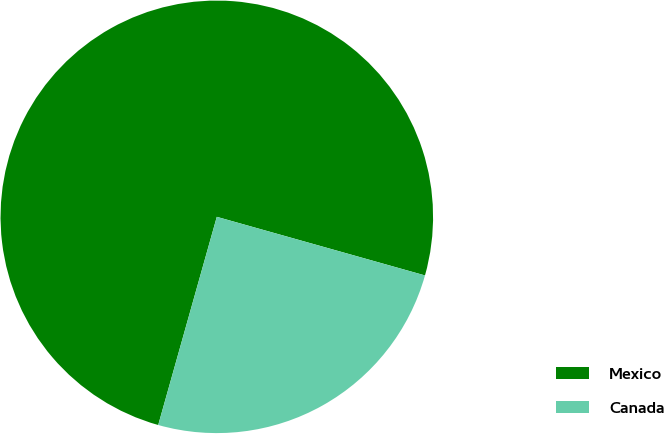Convert chart. <chart><loc_0><loc_0><loc_500><loc_500><pie_chart><fcel>Mexico<fcel>Canada<nl><fcel>75.0%<fcel>25.0%<nl></chart> 